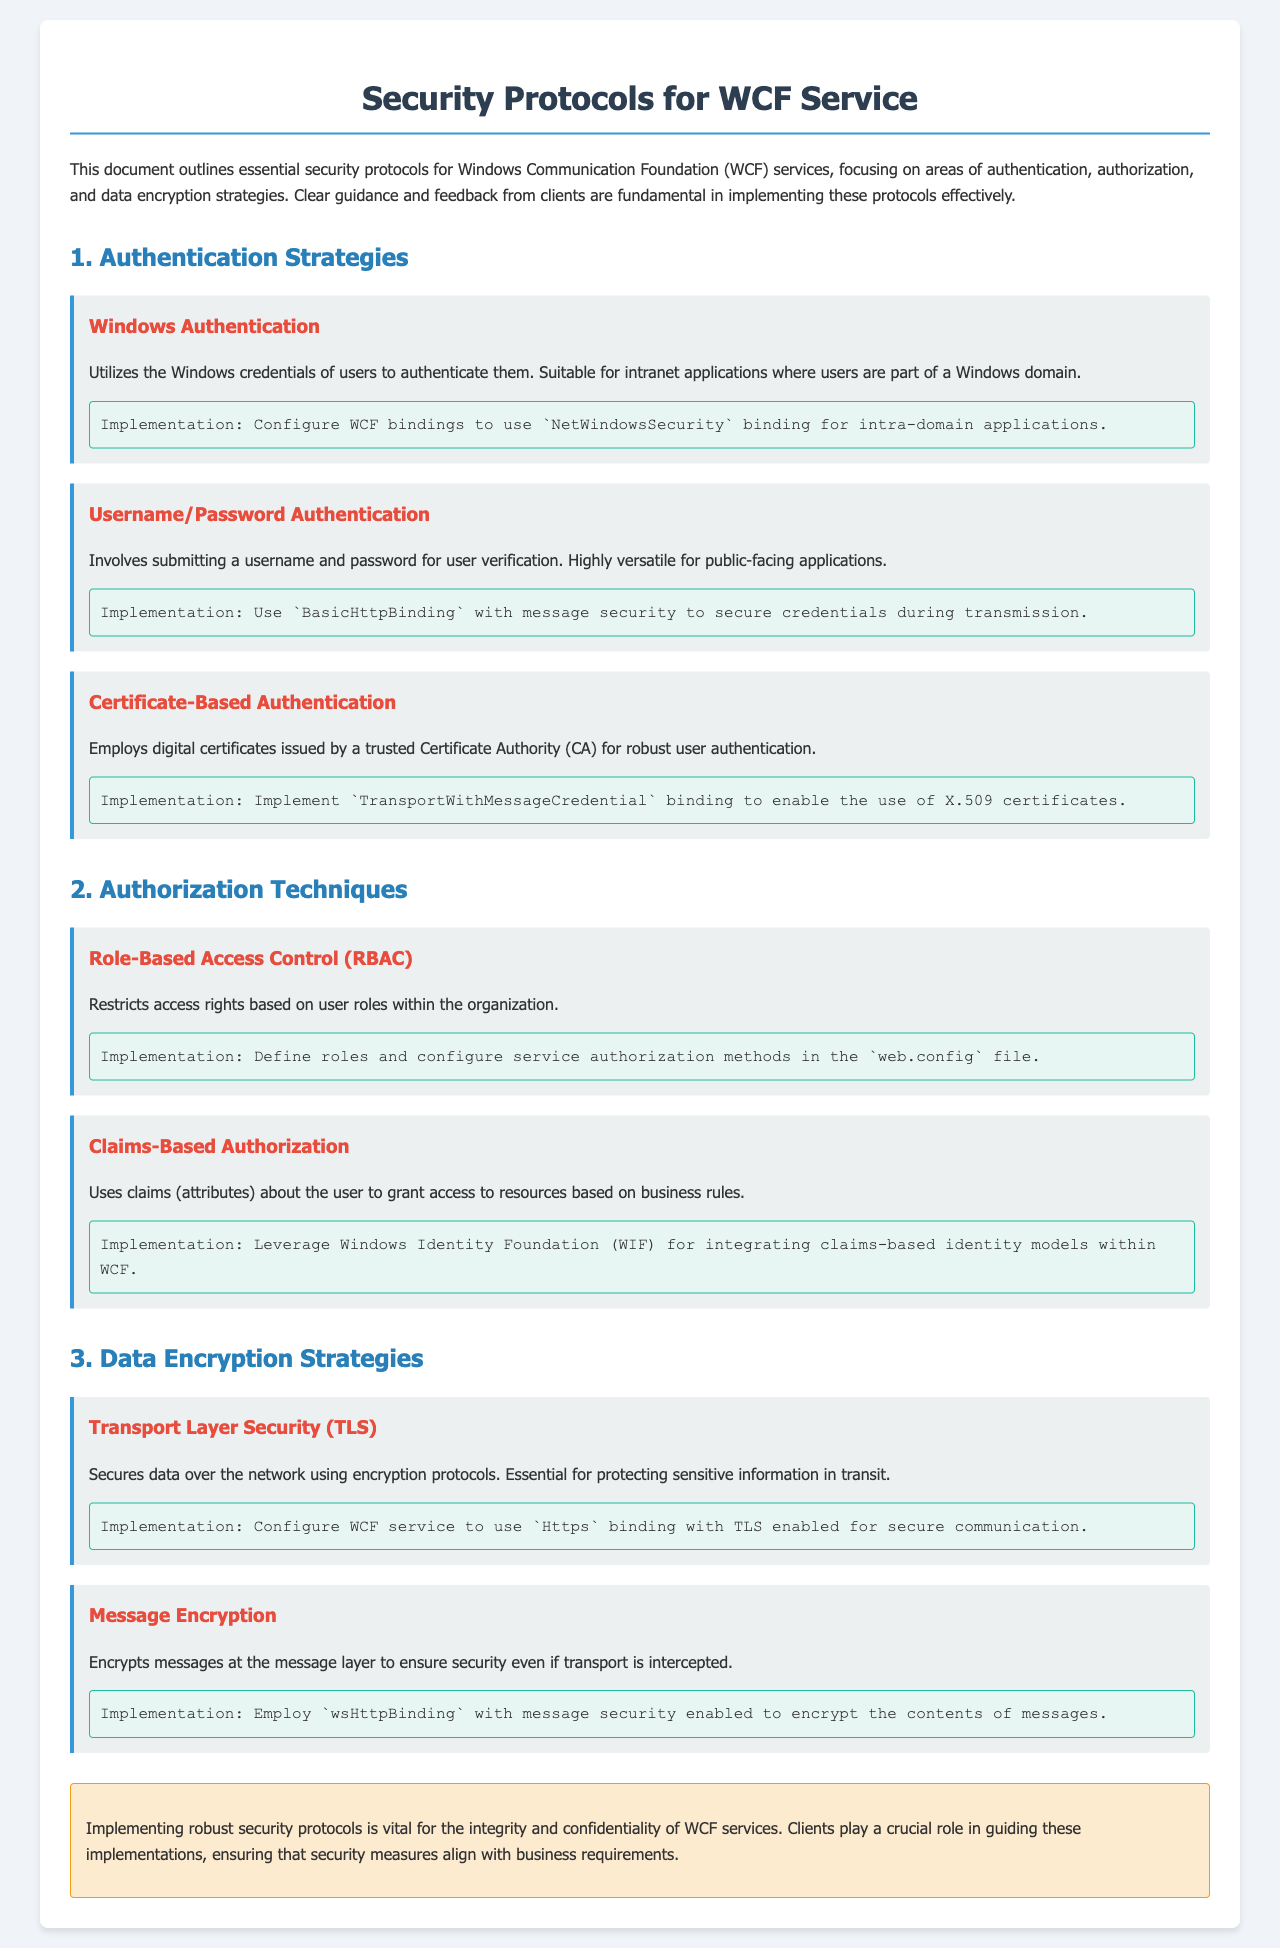What is the first strategy listed under Authentication? The first strategy listed under Authentication is "Windows Authentication."
Answer: Windows Authentication What binding is used for Certificate-Based Authentication? The document specifies the usage of "TransportWithMessageCredential" binding for Certificate-Based Authentication.
Answer: TransportWithMessageCredential How many Authorization Techniques are mentioned? The document outlines a total of two Authorization Techniques under the related section.
Answer: 2 What is the implementation method for Role-Based Access Control? The implementation method for Role-Based Access Control is defined in the "web.config" file.
Answer: web.config Which encryption method is essential for protecting sensitive information in transit? The document states that "Transport Layer Security (TLS)" secures data over the network using encryption protocols.
Answer: Transport Layer Security (TLS) What kind of authentication is suitable for public-facing applications? The document mentions "Username/Password Authentication" as suitable for public-facing applications.
Answer: Username/Password Authentication What is the main purpose of Claims-Based Authorization? Claims-Based Authorization uses claims about the user to grant access based on business rules.
Answer: Business rules What color represents the section headings in the document? The section headings in the document are represented by the color "#2980b9".
Answer: #2980b9 What is the focus of the outlined security protocols? The outlined security protocols focus on authentication, authorization, and data encryption strategies for WCF services.
Answer: Authentication, authorization, and data encryption strategies 